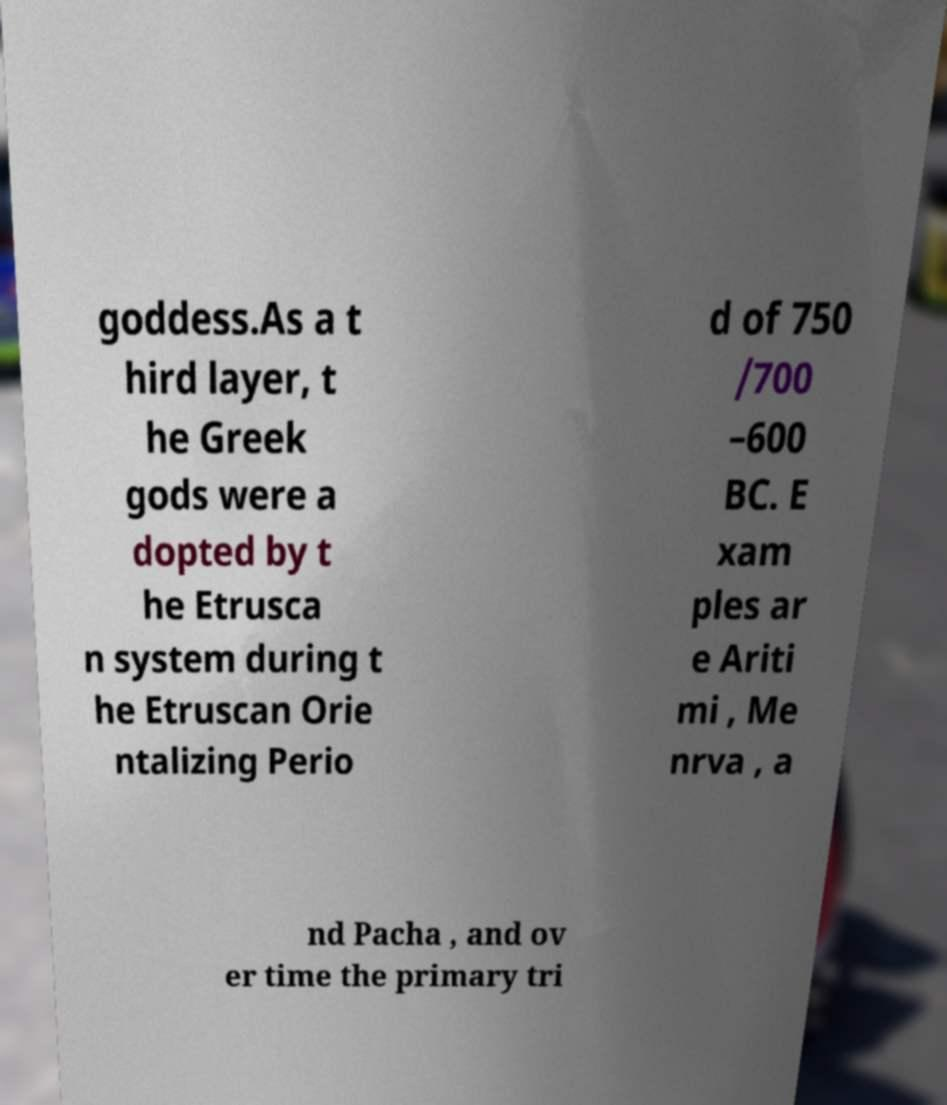Please identify and transcribe the text found in this image. goddess.As a t hird layer, t he Greek gods were a dopted by t he Etrusca n system during t he Etruscan Orie ntalizing Perio d of 750 /700 –600 BC. E xam ples ar e Ariti mi , Me nrva , a nd Pacha , and ov er time the primary tri 